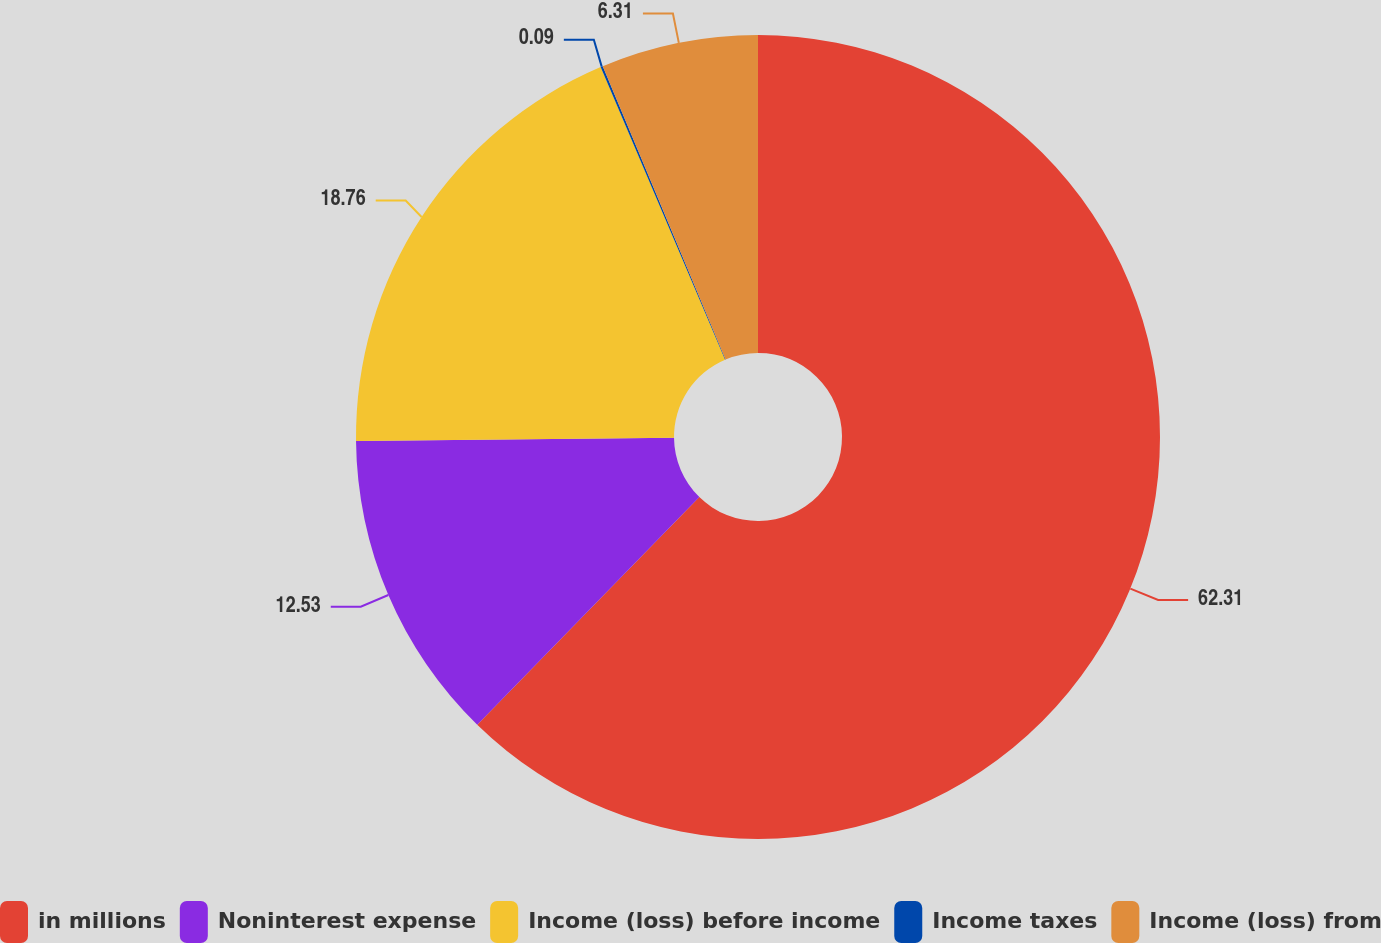Convert chart to OTSL. <chart><loc_0><loc_0><loc_500><loc_500><pie_chart><fcel>in millions<fcel>Noninterest expense<fcel>Income (loss) before income<fcel>Income taxes<fcel>Income (loss) from<nl><fcel>62.3%<fcel>12.53%<fcel>18.76%<fcel>0.09%<fcel>6.31%<nl></chart> 